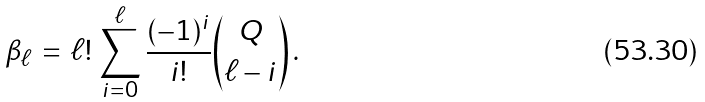Convert formula to latex. <formula><loc_0><loc_0><loc_500><loc_500>\beta _ { \ell } \, = \, \ell ! \, \sum _ { i = 0 } ^ { \ell } \frac { ( - 1 ) ^ { i } } { i ! } { Q \choose \ell - i } \, .</formula> 